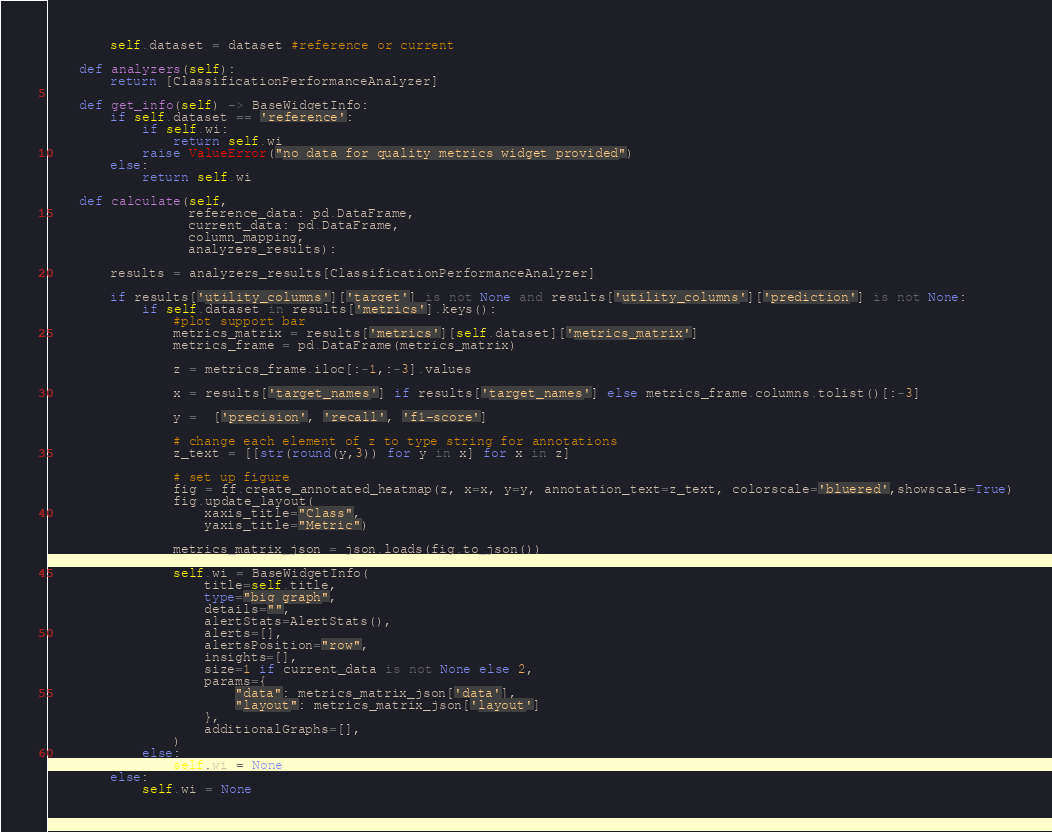Convert code to text. <code><loc_0><loc_0><loc_500><loc_500><_Python_>        self.dataset = dataset #reference or current

    def analyzers(self):   
        return [ClassificationPerformanceAnalyzer]

    def get_info(self) -> BaseWidgetInfo:
        if self.dataset == 'reference':
            if self.wi:
                return self.wi
            raise ValueError("no data for quality metrics widget provided")
        else:
            return self.wi

    def calculate(self,
                  reference_data: pd.DataFrame,
                  current_data: pd.DataFrame,
                  column_mapping,
                  analyzers_results):
        
        results = analyzers_results[ClassificationPerformanceAnalyzer]

        if results['utility_columns']['target'] is not None and results['utility_columns']['prediction'] is not None:
            if self.dataset in results['metrics'].keys():          
                #plot support bar
                metrics_matrix = results['metrics'][self.dataset]['metrics_matrix']
                metrics_frame = pd.DataFrame(metrics_matrix)

                z = metrics_frame.iloc[:-1,:-3].values

                x = results['target_names'] if results['target_names'] else metrics_frame.columns.tolist()[:-3]

                y =  ['precision', 'recall', 'f1-score']

                # change each element of z to type string for annotations
                z_text = [[str(round(y,3)) for y in x] for x in z]

                # set up figure 
                fig = ff.create_annotated_heatmap(z, x=x, y=y, annotation_text=z_text, colorscale='bluered',showscale=True)
                fig.update_layout(
                    xaxis_title="Class", 
                    yaxis_title="Metric")

                metrics_matrix_json = json.loads(fig.to_json())

                self.wi = BaseWidgetInfo(
                    title=self.title,
                    type="big_graph",
                    details="",
                    alertStats=AlertStats(),
                    alerts=[],
                    alertsPosition="row",
                    insights=[],
                    size=1 if current_data is not None else 2,
                    params={
                        "data": metrics_matrix_json['data'],
                        "layout": metrics_matrix_json['layout']
                    },
                    additionalGraphs=[],
                )
            else:
                self.wi = None
        else:
            self.wi = None

</code> 